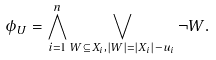Convert formula to latex. <formula><loc_0><loc_0><loc_500><loc_500>\phi _ { U } = \bigwedge _ { i = 1 } ^ { n } \bigvee _ { W \subseteq X _ { i } , | W | = | X _ { i } | - u _ { i } } \neg W .</formula> 